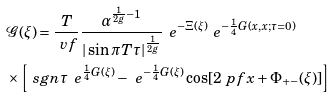Convert formula to latex. <formula><loc_0><loc_0><loc_500><loc_500>& \mathcal { G } ( \xi ) = \frac { T } { \ v f } \frac { \alpha ^ { \frac { 1 } { 2 g } - 1 } } { | \sin \pi T \tau | ^ { \frac { 1 } { 2 g } } } \, \ e ^ { - \Xi ( \xi ) } \ e ^ { - \frac { 1 } { 4 } G ( x , x ; \tau = 0 ) } \\ & \times \left [ \ s g n \tau \, \ e ^ { \frac { 1 } { 4 } G ( \xi ) } - \ e ^ { - \frac { 1 } { 4 } G ( \xi ) } \cos [ 2 \ p f x + \Phi _ { + - } ( \xi ) ] \right ]</formula> 